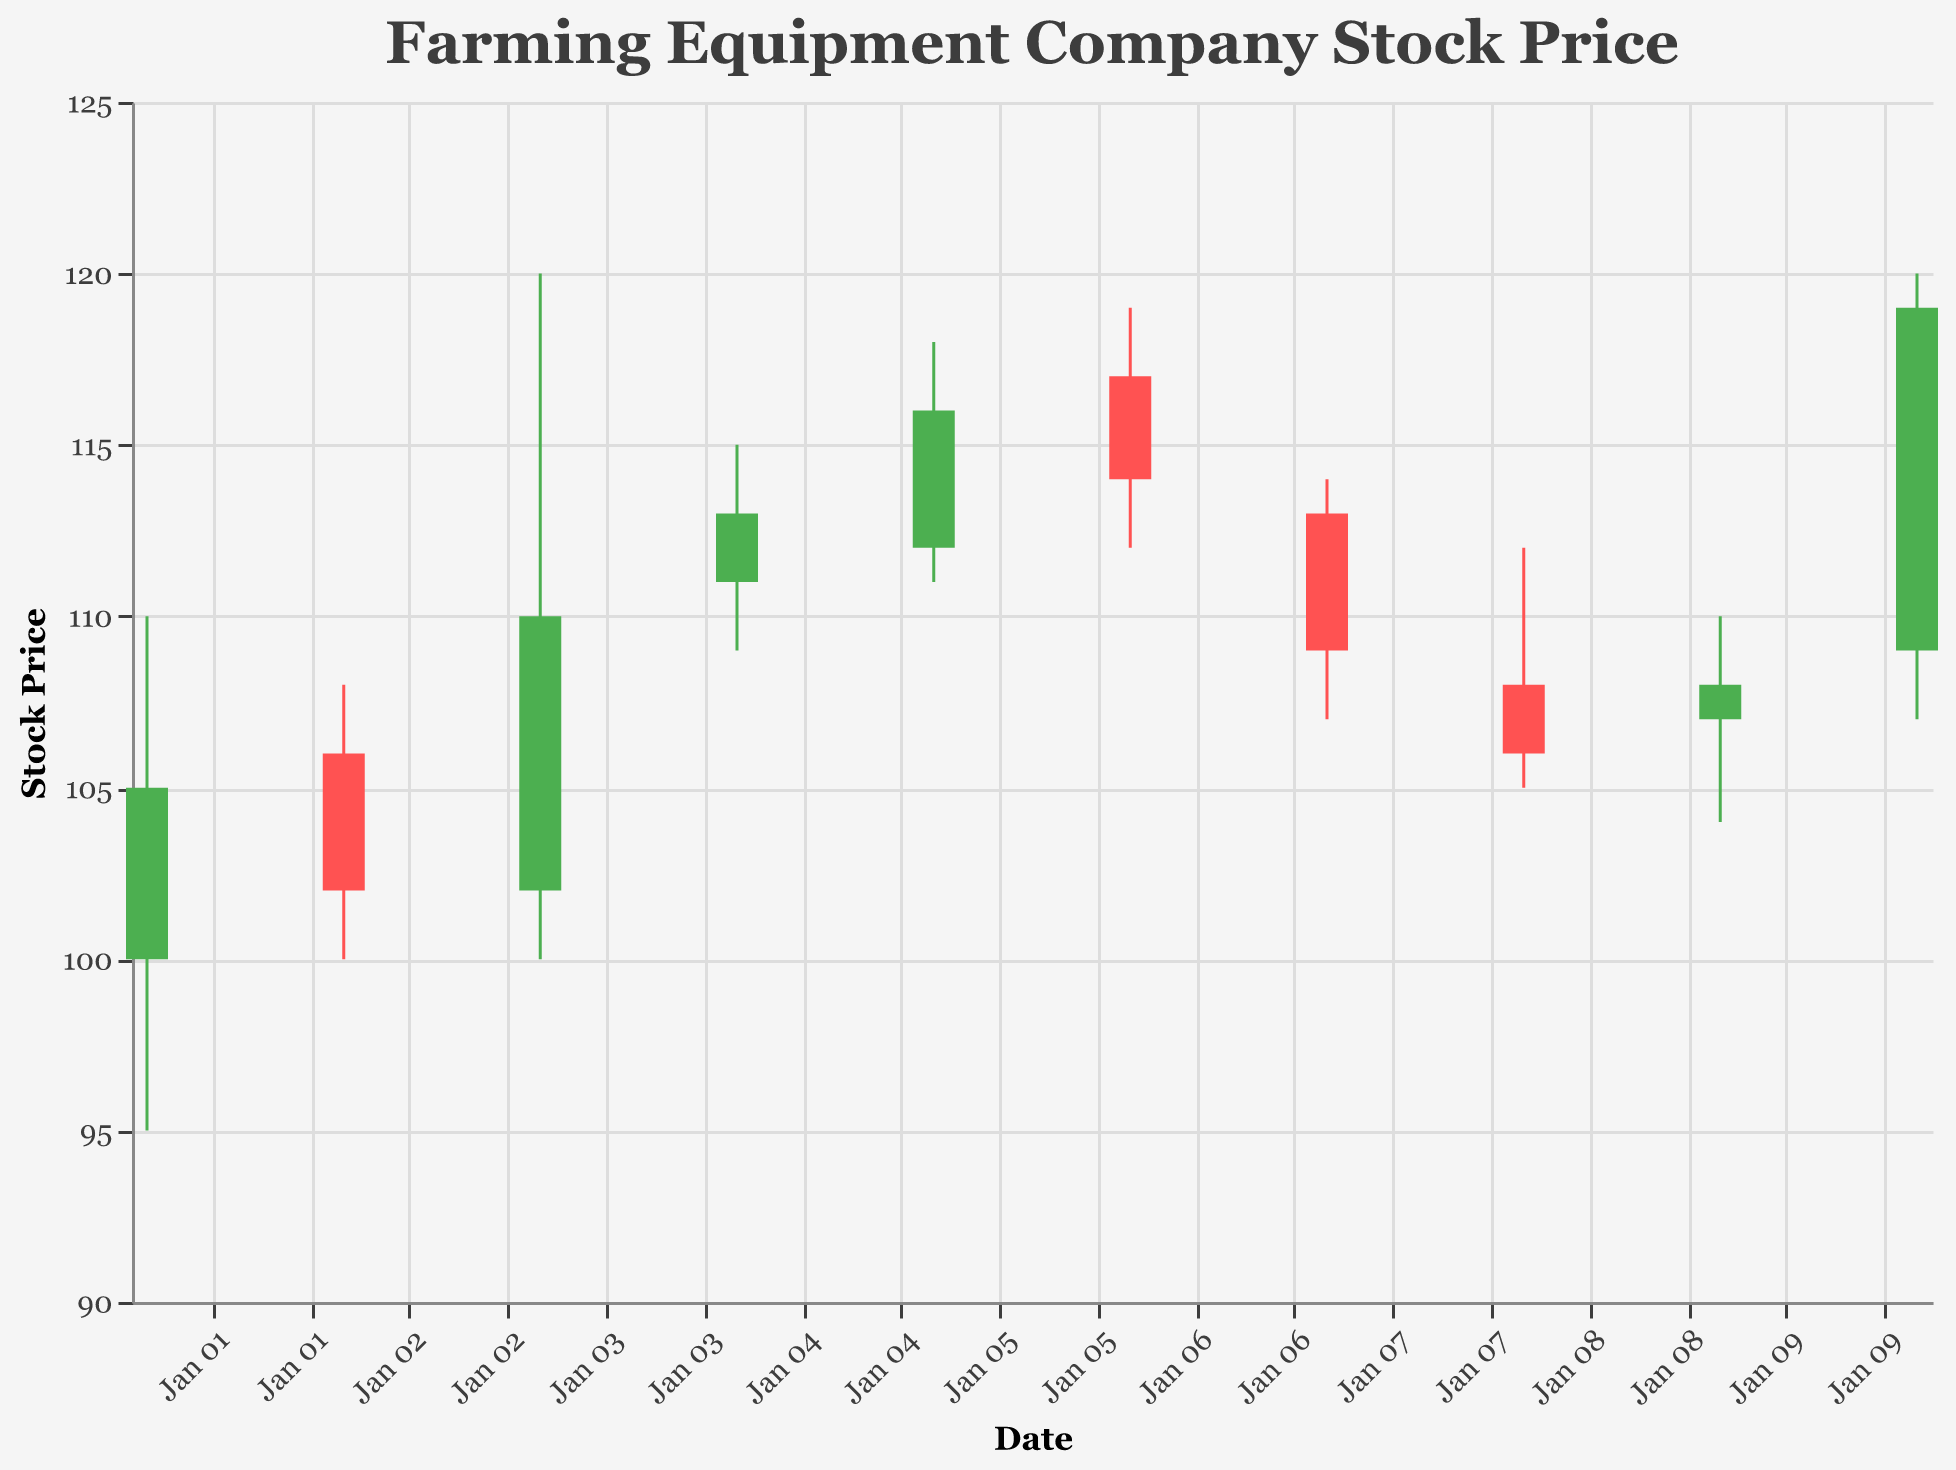Which date shows the highest volume of trading? The plot shows trading volumes for each date. Simply find the highest volume bar.
Answer: January 5, 2023 What was the stock's lowest price during the period? Scan the "Low" values across the entire plot. The lowest point reaches 95.
Answer: January 1, 2023 On which date did the stock open at its highest price and what was that price? Compare the "Open" prices represented by the top of each green or red bar. The highest "Open" value is 117.
Answer: January 6, 2023 Which day had the biggest difference between the high and low prices? Calculate the difference between the "High" and "Low" for each date. The day with the highest difference is January 3, 2023, with a difference of 20 (120 - 100).
Answer: January 3, 2023 What is the overall trend of the stock from January 1 to January 10? Track the close prices from January 1, 2023, to January 10, 2023. Comparing the first close price (105) and the last close price (119), the overall trend is an increase.
Answer: Upward On which date did the stock close at its lowest price? Find the lowest "Close" price at the bottom of each bar. The lowest "Close" is 102.
Answer: January 2, 2023 Compare the closing prices of January 5 and January 6. Which one is higher? Look at the ending point of the bars for January 5 and January 6. The closing prices are 116 and 114, respectively.
Answer: January 5, 2023 How many days did the stock close higher than it opened? Count the number of green bars, where the "Close" price is higher than the "Open" price. There are 5 such days.
Answer: 5 days 